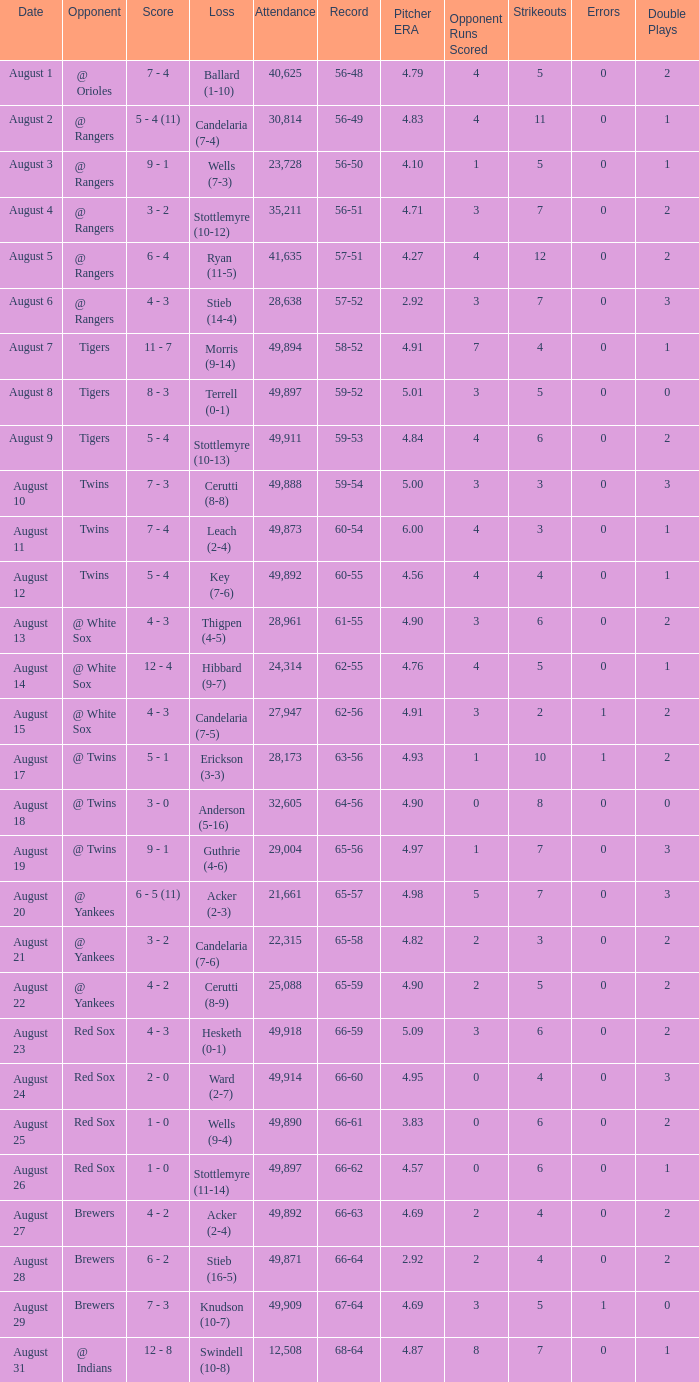What was the Attendance high on August 28? 49871.0. 